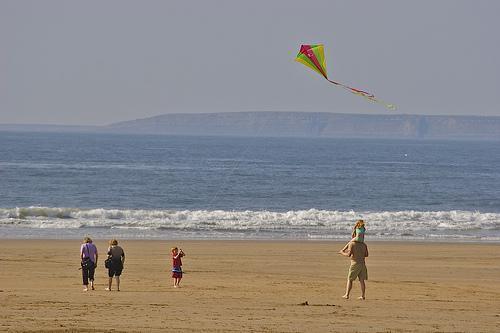How many people do you see?
Give a very brief answer. 5. How many people or in the pic?
Give a very brief answer. 5. How many toilet covers are there?
Give a very brief answer. 0. 